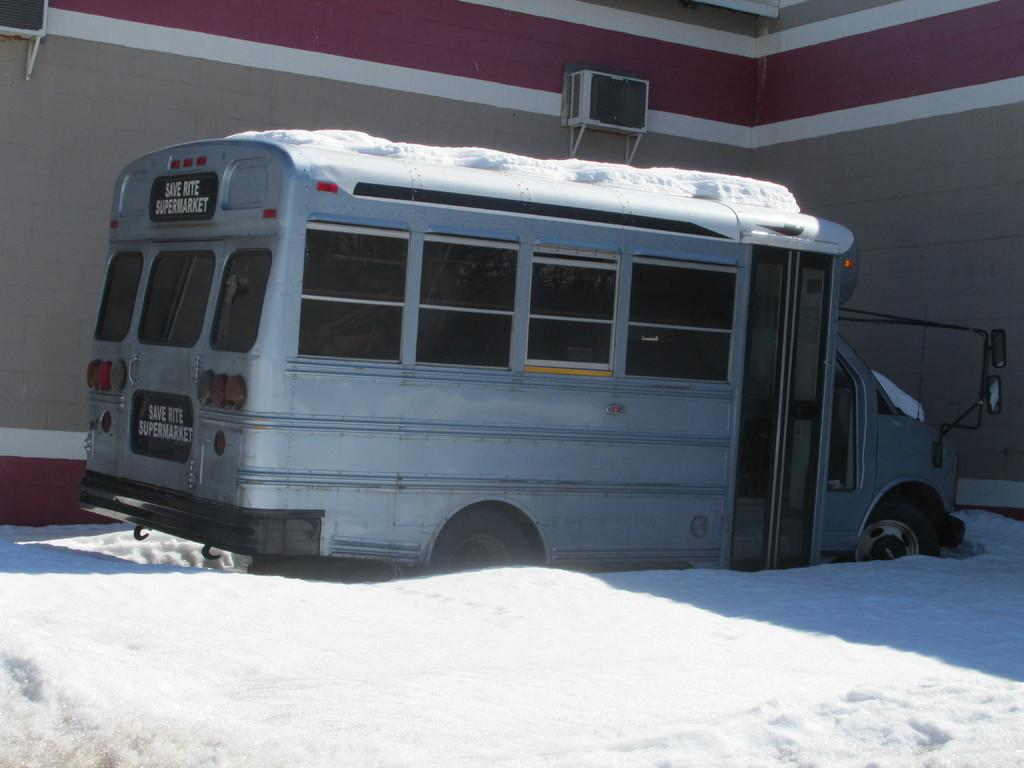What is the main subject in the center of the image? There is a vehicle in the center of the image. What is the terrain surrounding the vehicle? The vehicle is on the snow. What can be seen in the background of the image? There is a building in the background of the image. What additional details can be observed on the building? Air conditioning units (AC's) are present on the building. Can you see a toad hopping near the vehicle in the image? There is no toad present in the image. What type of parent is shown interacting with the vehicle in the image? There are no parents depicted in the image; it features a vehicle on the snow with a building in the background. 